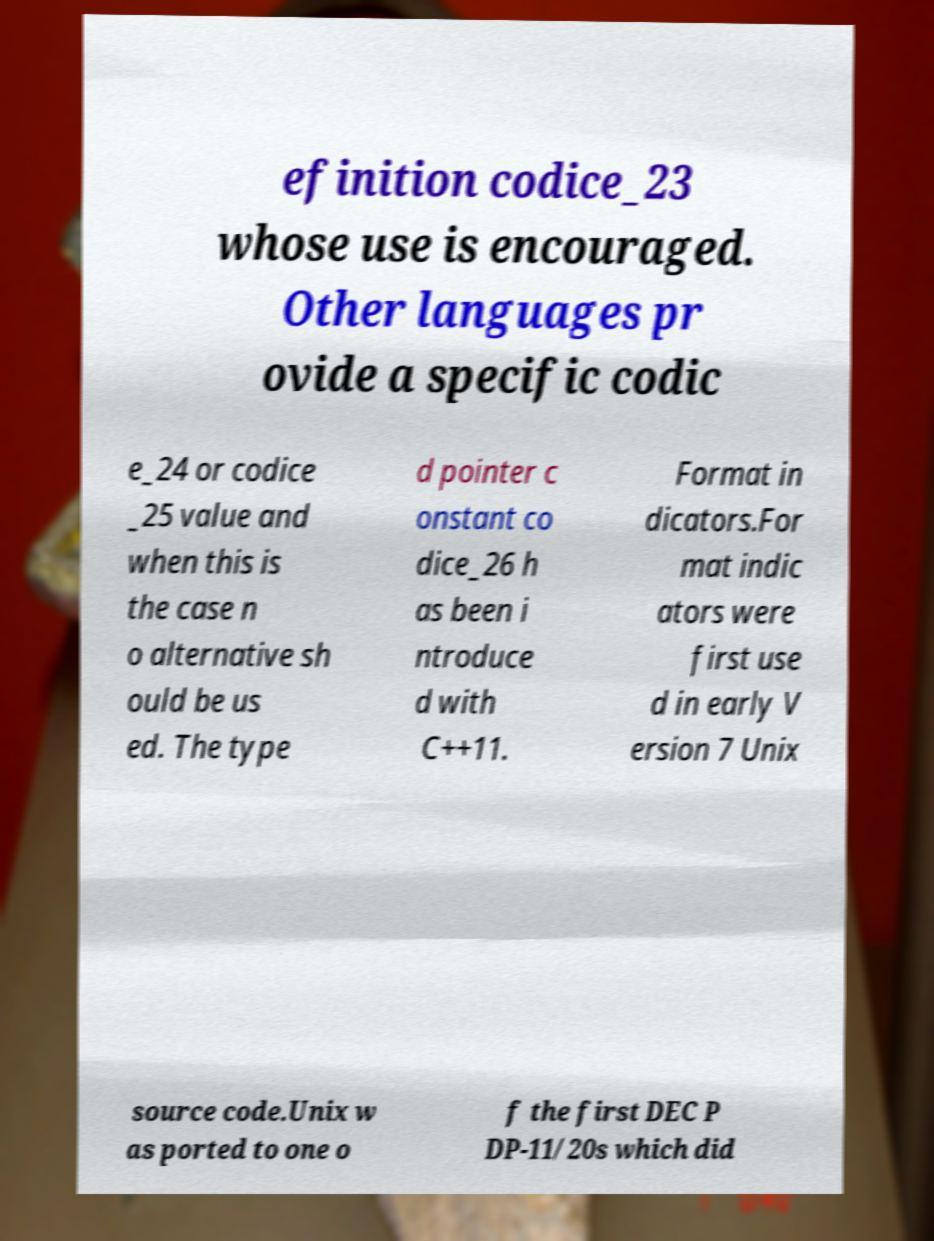What messages or text are displayed in this image? I need them in a readable, typed format. efinition codice_23 whose use is encouraged. Other languages pr ovide a specific codic e_24 or codice _25 value and when this is the case n o alternative sh ould be us ed. The type d pointer c onstant co dice_26 h as been i ntroduce d with C++11. Format in dicators.For mat indic ators were first use d in early V ersion 7 Unix source code.Unix w as ported to one o f the first DEC P DP-11/20s which did 